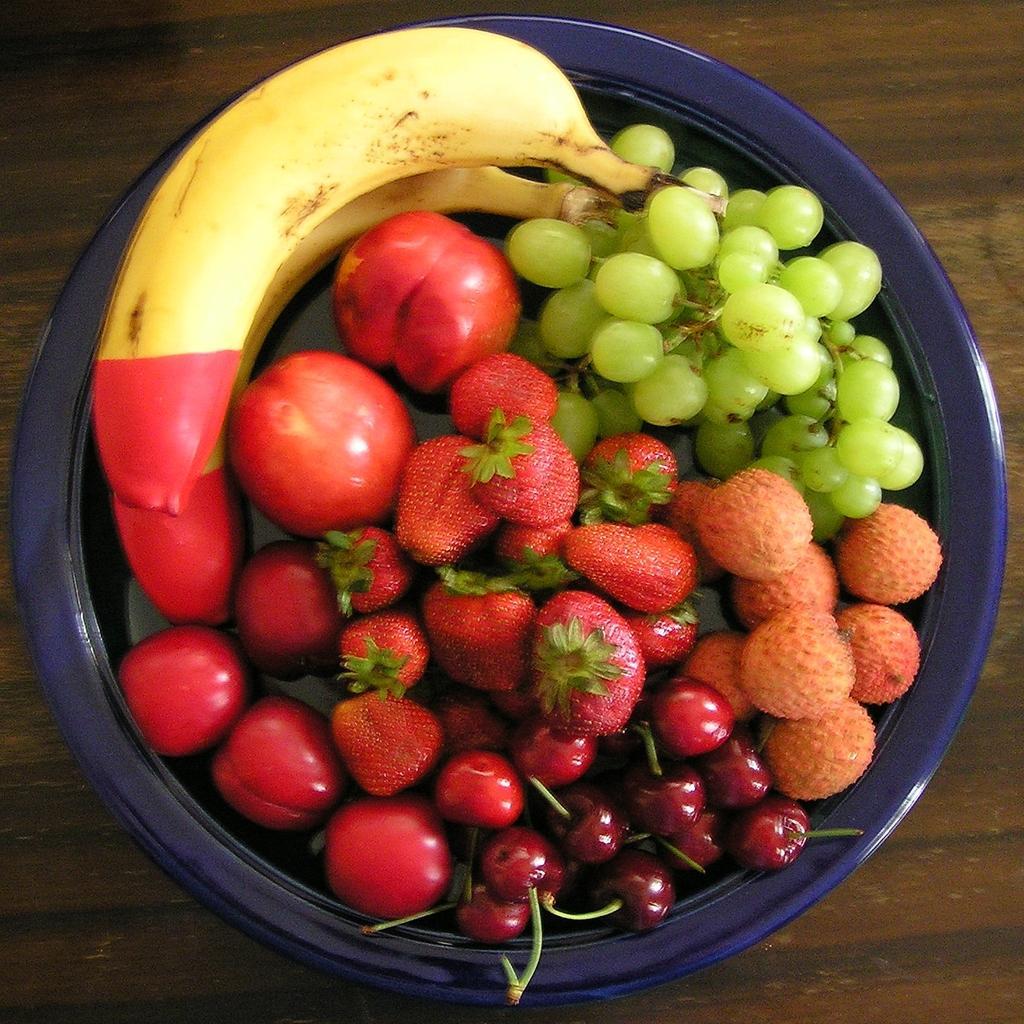In one or two sentences, can you explain what this image depicts? On a wooden table we can see fruits in a bowl. We can see bananas, grapes, strawberries, cherries, leeches and other fruits. 